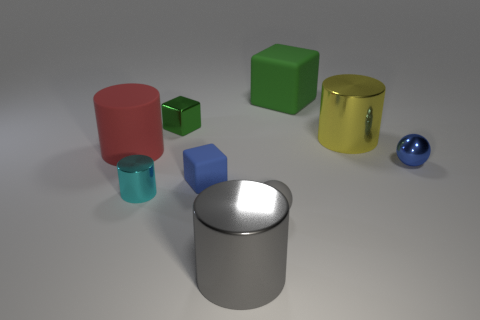How many green blocks must be subtracted to get 1 green blocks? 1 Add 1 small gray cylinders. How many objects exist? 10 Subtract all big matte cylinders. How many cylinders are left? 3 Subtract 0 green balls. How many objects are left? 9 Subtract all balls. How many objects are left? 7 Subtract all gray spheres. Subtract all cyan cubes. How many spheres are left? 1 Subtract all yellow blocks. How many red balls are left? 0 Subtract all tiny metal blocks. Subtract all large gray objects. How many objects are left? 7 Add 9 large red rubber cylinders. How many large red rubber cylinders are left? 10 Add 5 large gray cubes. How many large gray cubes exist? 5 